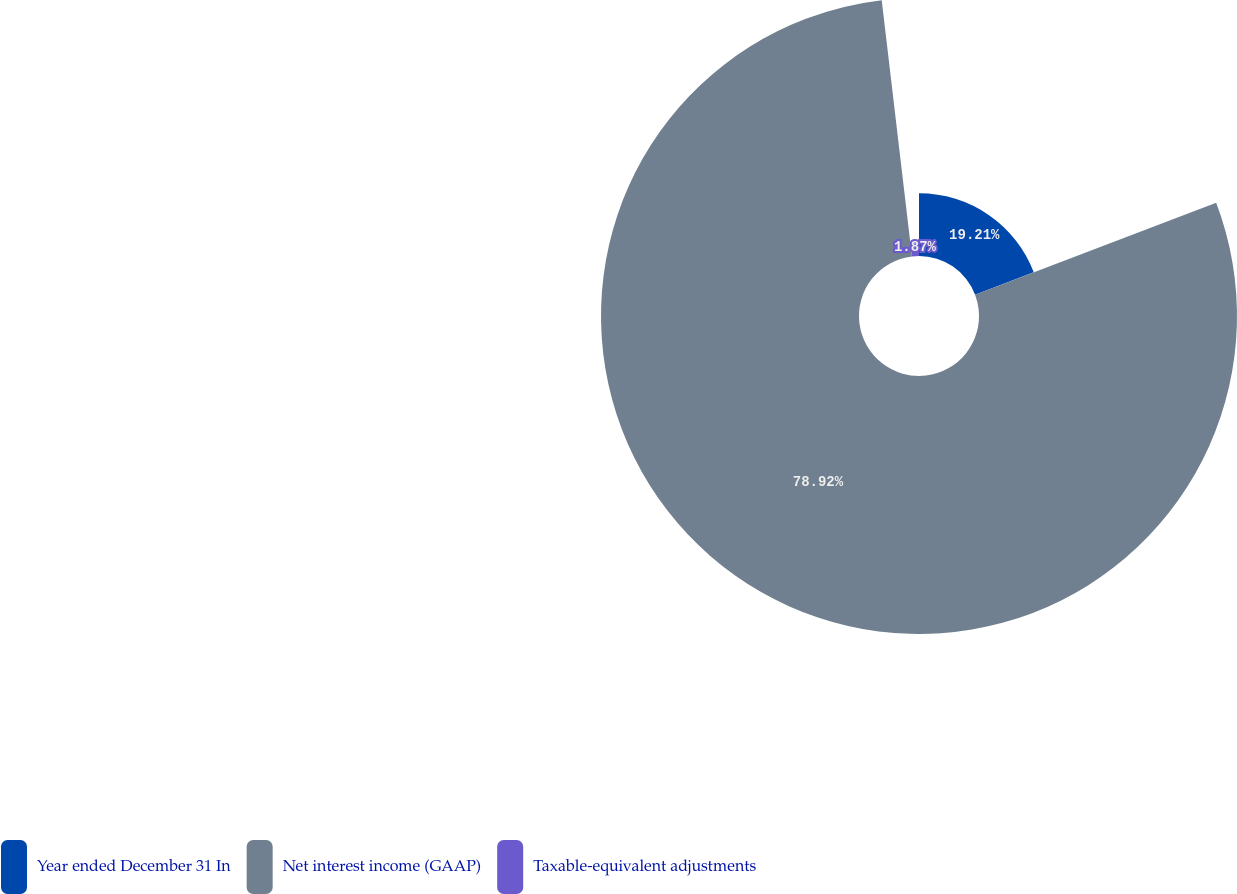<chart> <loc_0><loc_0><loc_500><loc_500><pie_chart><fcel>Year ended December 31 In<fcel>Net interest income (GAAP)<fcel>Taxable-equivalent adjustments<nl><fcel>19.21%<fcel>78.92%<fcel>1.87%<nl></chart> 